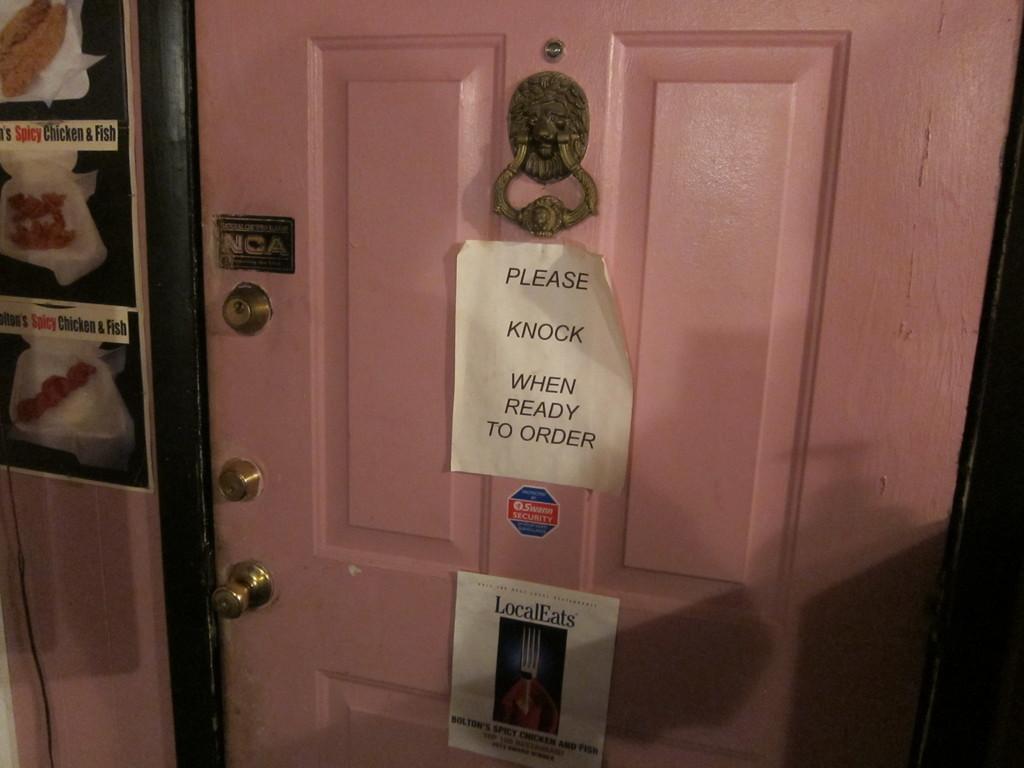What should you do when you're ready to order?
Your answer should be very brief. Knock. What should you do when you order?
Provide a succinct answer. Knock. 